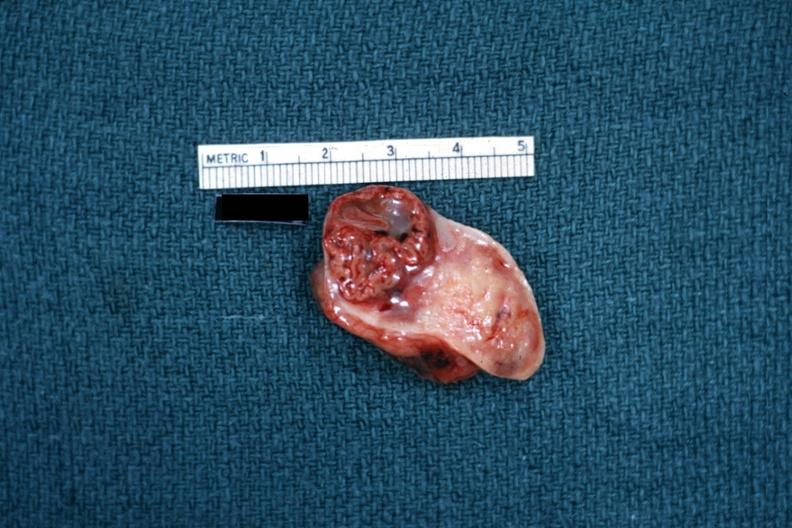what is present?
Answer the question using a single word or phrase. Female reproductive 